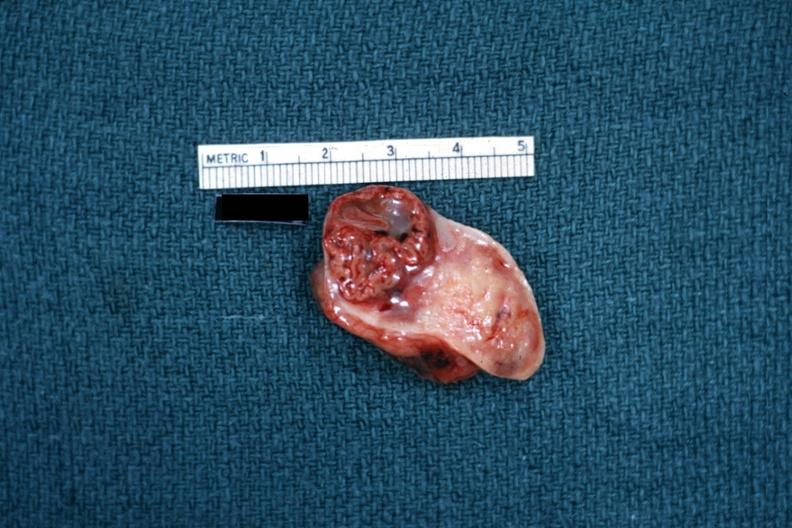what is present?
Answer the question using a single word or phrase. Female reproductive 